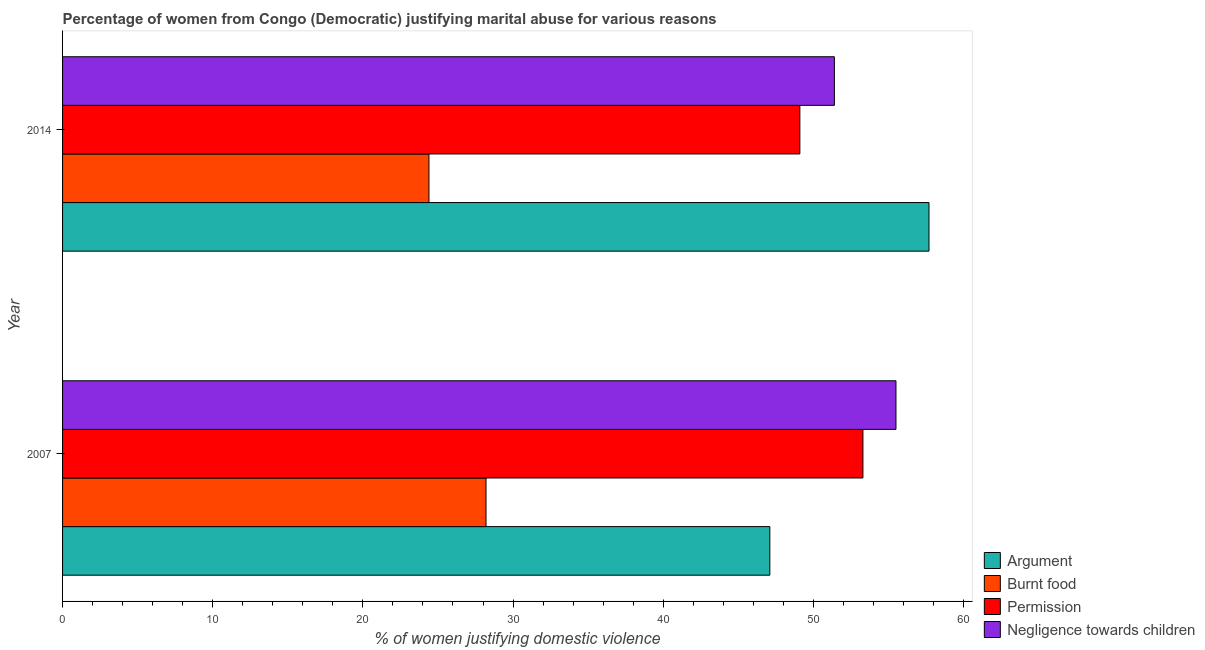How many different coloured bars are there?
Your response must be concise. 4. Are the number of bars per tick equal to the number of legend labels?
Offer a terse response. Yes. How many bars are there on the 2nd tick from the top?
Your answer should be very brief. 4. How many bars are there on the 2nd tick from the bottom?
Provide a short and direct response. 4. What is the label of the 1st group of bars from the top?
Provide a short and direct response. 2014. In how many cases, is the number of bars for a given year not equal to the number of legend labels?
Provide a succinct answer. 0. What is the percentage of women justifying abuse for showing negligence towards children in 2007?
Make the answer very short. 55.5. Across all years, what is the maximum percentage of women justifying abuse in the case of an argument?
Provide a short and direct response. 57.7. Across all years, what is the minimum percentage of women justifying abuse for going without permission?
Keep it short and to the point. 49.1. In which year was the percentage of women justifying abuse in the case of an argument minimum?
Offer a very short reply. 2007. What is the total percentage of women justifying abuse for burning food in the graph?
Provide a short and direct response. 52.6. What is the difference between the percentage of women justifying abuse for burning food in 2014 and the percentage of women justifying abuse for going without permission in 2007?
Keep it short and to the point. -28.9. What is the average percentage of women justifying abuse for showing negligence towards children per year?
Provide a short and direct response. 53.45. In the year 2007, what is the difference between the percentage of women justifying abuse for going without permission and percentage of women justifying abuse for burning food?
Offer a terse response. 25.1. In how many years, is the percentage of women justifying abuse for burning food greater than 28 %?
Keep it short and to the point. 1. What is the ratio of the percentage of women justifying abuse for burning food in 2007 to that in 2014?
Your response must be concise. 1.16. Is the percentage of women justifying abuse for showing negligence towards children in 2007 less than that in 2014?
Offer a terse response. No. Is the difference between the percentage of women justifying abuse for burning food in 2007 and 2014 greater than the difference between the percentage of women justifying abuse for showing negligence towards children in 2007 and 2014?
Make the answer very short. No. What does the 1st bar from the top in 2014 represents?
Offer a very short reply. Negligence towards children. What does the 2nd bar from the bottom in 2007 represents?
Your response must be concise. Burnt food. Is it the case that in every year, the sum of the percentage of women justifying abuse in the case of an argument and percentage of women justifying abuse for burning food is greater than the percentage of women justifying abuse for going without permission?
Make the answer very short. Yes. How many years are there in the graph?
Offer a very short reply. 2. What is the difference between two consecutive major ticks on the X-axis?
Give a very brief answer. 10. Are the values on the major ticks of X-axis written in scientific E-notation?
Your answer should be very brief. No. How many legend labels are there?
Your answer should be very brief. 4. How are the legend labels stacked?
Offer a very short reply. Vertical. What is the title of the graph?
Your response must be concise. Percentage of women from Congo (Democratic) justifying marital abuse for various reasons. Does "United Kingdom" appear as one of the legend labels in the graph?
Your answer should be very brief. No. What is the label or title of the X-axis?
Provide a short and direct response. % of women justifying domestic violence. What is the % of women justifying domestic violence of Argument in 2007?
Your answer should be very brief. 47.1. What is the % of women justifying domestic violence of Burnt food in 2007?
Your answer should be compact. 28.2. What is the % of women justifying domestic violence of Permission in 2007?
Offer a very short reply. 53.3. What is the % of women justifying domestic violence in Negligence towards children in 2007?
Make the answer very short. 55.5. What is the % of women justifying domestic violence in Argument in 2014?
Keep it short and to the point. 57.7. What is the % of women justifying domestic violence in Burnt food in 2014?
Offer a terse response. 24.4. What is the % of women justifying domestic violence of Permission in 2014?
Your response must be concise. 49.1. What is the % of women justifying domestic violence of Negligence towards children in 2014?
Offer a very short reply. 51.4. Across all years, what is the maximum % of women justifying domestic violence in Argument?
Make the answer very short. 57.7. Across all years, what is the maximum % of women justifying domestic violence of Burnt food?
Your answer should be compact. 28.2. Across all years, what is the maximum % of women justifying domestic violence in Permission?
Give a very brief answer. 53.3. Across all years, what is the maximum % of women justifying domestic violence of Negligence towards children?
Offer a terse response. 55.5. Across all years, what is the minimum % of women justifying domestic violence in Argument?
Ensure brevity in your answer.  47.1. Across all years, what is the minimum % of women justifying domestic violence in Burnt food?
Offer a very short reply. 24.4. Across all years, what is the minimum % of women justifying domestic violence in Permission?
Provide a succinct answer. 49.1. Across all years, what is the minimum % of women justifying domestic violence of Negligence towards children?
Provide a short and direct response. 51.4. What is the total % of women justifying domestic violence of Argument in the graph?
Keep it short and to the point. 104.8. What is the total % of women justifying domestic violence of Burnt food in the graph?
Provide a succinct answer. 52.6. What is the total % of women justifying domestic violence in Permission in the graph?
Make the answer very short. 102.4. What is the total % of women justifying domestic violence in Negligence towards children in the graph?
Provide a short and direct response. 106.9. What is the difference between the % of women justifying domestic violence in Permission in 2007 and that in 2014?
Provide a short and direct response. 4.2. What is the difference between the % of women justifying domestic violence in Argument in 2007 and the % of women justifying domestic violence in Burnt food in 2014?
Your response must be concise. 22.7. What is the difference between the % of women justifying domestic violence in Argument in 2007 and the % of women justifying domestic violence in Permission in 2014?
Your answer should be very brief. -2. What is the difference between the % of women justifying domestic violence of Burnt food in 2007 and the % of women justifying domestic violence of Permission in 2014?
Provide a succinct answer. -20.9. What is the difference between the % of women justifying domestic violence of Burnt food in 2007 and the % of women justifying domestic violence of Negligence towards children in 2014?
Keep it short and to the point. -23.2. What is the average % of women justifying domestic violence in Argument per year?
Your answer should be very brief. 52.4. What is the average % of women justifying domestic violence of Burnt food per year?
Offer a terse response. 26.3. What is the average % of women justifying domestic violence in Permission per year?
Give a very brief answer. 51.2. What is the average % of women justifying domestic violence of Negligence towards children per year?
Keep it short and to the point. 53.45. In the year 2007, what is the difference between the % of women justifying domestic violence in Argument and % of women justifying domestic violence in Burnt food?
Offer a terse response. 18.9. In the year 2007, what is the difference between the % of women justifying domestic violence of Argument and % of women justifying domestic violence of Permission?
Your answer should be very brief. -6.2. In the year 2007, what is the difference between the % of women justifying domestic violence of Argument and % of women justifying domestic violence of Negligence towards children?
Give a very brief answer. -8.4. In the year 2007, what is the difference between the % of women justifying domestic violence of Burnt food and % of women justifying domestic violence of Permission?
Make the answer very short. -25.1. In the year 2007, what is the difference between the % of women justifying domestic violence of Burnt food and % of women justifying domestic violence of Negligence towards children?
Keep it short and to the point. -27.3. In the year 2014, what is the difference between the % of women justifying domestic violence of Argument and % of women justifying domestic violence of Burnt food?
Provide a succinct answer. 33.3. In the year 2014, what is the difference between the % of women justifying domestic violence of Argument and % of women justifying domestic violence of Permission?
Keep it short and to the point. 8.6. In the year 2014, what is the difference between the % of women justifying domestic violence in Burnt food and % of women justifying domestic violence in Permission?
Your answer should be compact. -24.7. In the year 2014, what is the difference between the % of women justifying domestic violence in Burnt food and % of women justifying domestic violence in Negligence towards children?
Offer a terse response. -27. What is the ratio of the % of women justifying domestic violence of Argument in 2007 to that in 2014?
Your answer should be compact. 0.82. What is the ratio of the % of women justifying domestic violence in Burnt food in 2007 to that in 2014?
Keep it short and to the point. 1.16. What is the ratio of the % of women justifying domestic violence in Permission in 2007 to that in 2014?
Your response must be concise. 1.09. What is the ratio of the % of women justifying domestic violence of Negligence towards children in 2007 to that in 2014?
Make the answer very short. 1.08. What is the difference between the highest and the second highest % of women justifying domestic violence of Permission?
Provide a short and direct response. 4.2. What is the difference between the highest and the second highest % of women justifying domestic violence of Negligence towards children?
Offer a very short reply. 4.1. What is the difference between the highest and the lowest % of women justifying domestic violence of Burnt food?
Your answer should be very brief. 3.8. 